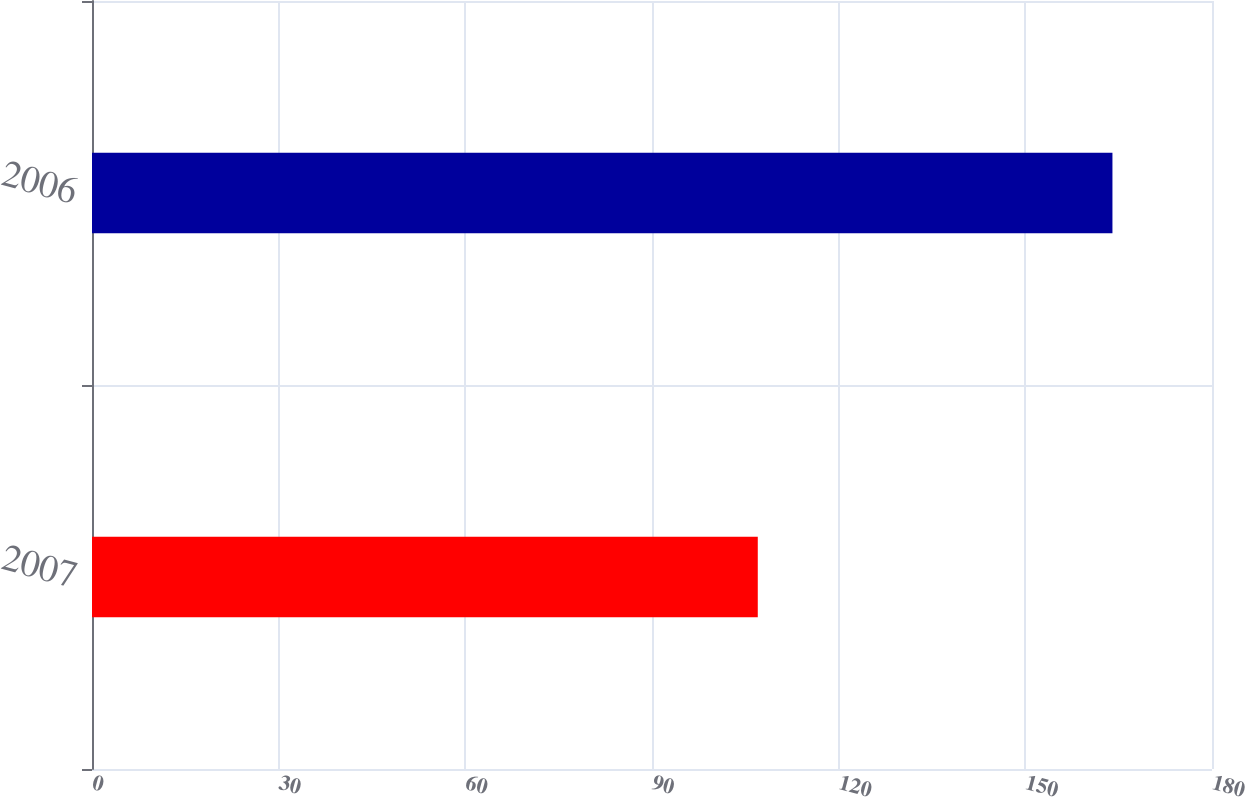Convert chart to OTSL. <chart><loc_0><loc_0><loc_500><loc_500><bar_chart><fcel>2007<fcel>2006<nl><fcel>107<fcel>164<nl></chart> 